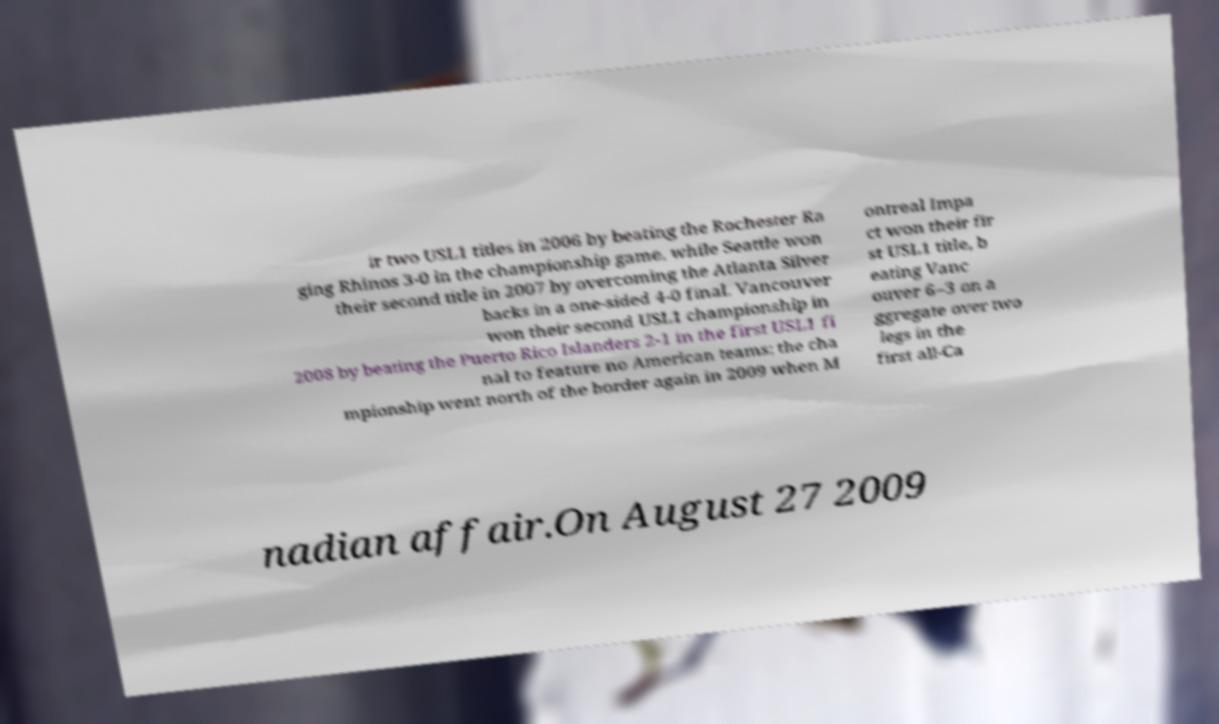Can you read and provide the text displayed in the image?This photo seems to have some interesting text. Can you extract and type it out for me? ir two USL1 titles in 2006 by beating the Rochester Ra ging Rhinos 3-0 in the championship game, while Seattle won their second title in 2007 by overcoming the Atlanta Silver backs in a one-sided 4-0 final. Vancouver won their second USL1 championship in 2008 by beating the Puerto Rico Islanders 2-1 in the first USL1 fi nal to feature no American teams; the cha mpionship went north of the border again in 2009 when M ontreal Impa ct won their fir st USL1 title, b eating Vanc ouver 6–3 on a ggregate over two legs in the first all-Ca nadian affair.On August 27 2009 